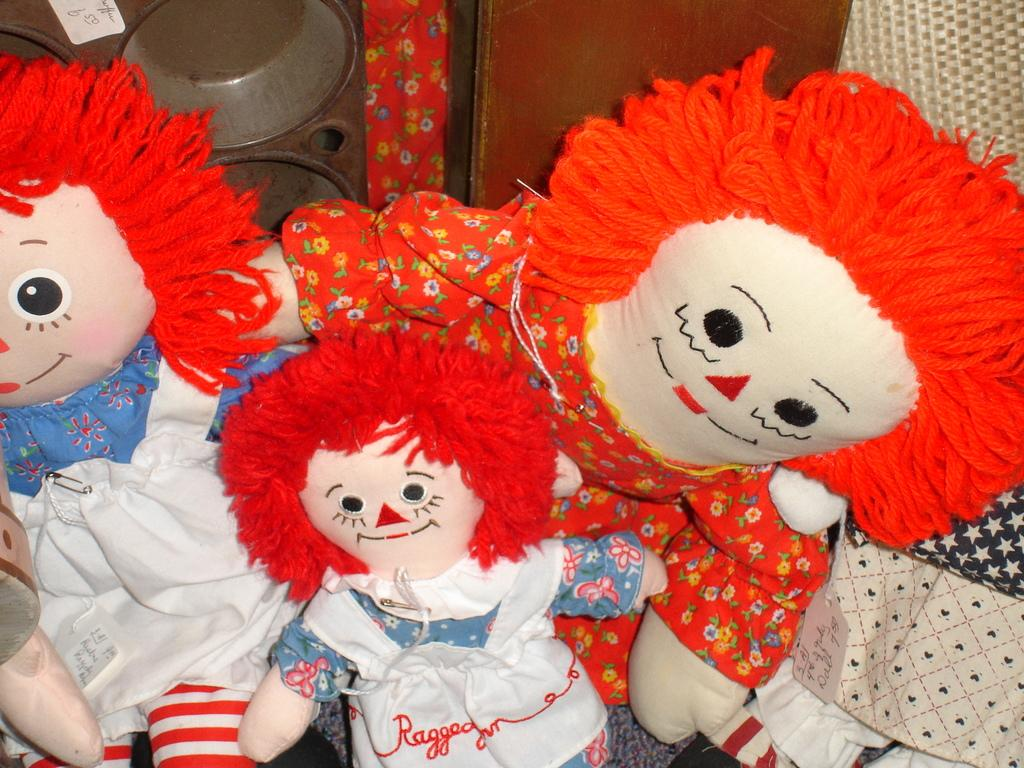What type of items can be seen in the image? There are toys in the image. Can you describe the placement of the toys in the image? The toys are placed on the floor. What else can be seen on the floor behind the toys? There are objects placed on the floor behind the toys. What type of loaf can be heard in the image? There is no loaf present in the image, and therefore no sound can be heard. 